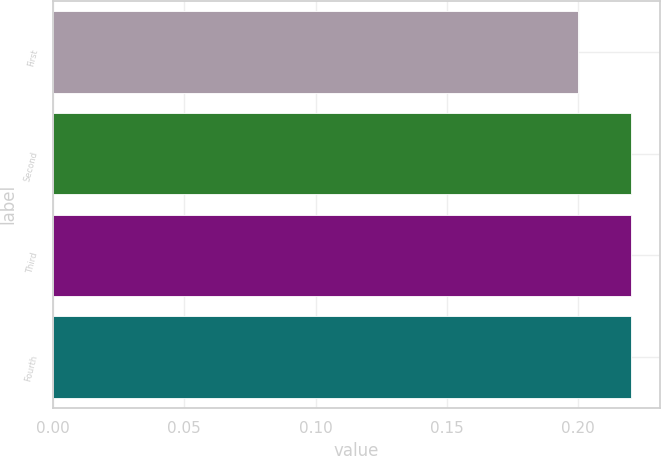<chart> <loc_0><loc_0><loc_500><loc_500><bar_chart><fcel>First<fcel>Second<fcel>Third<fcel>Fourth<nl><fcel>0.2<fcel>0.22<fcel>0.22<fcel>0.22<nl></chart> 